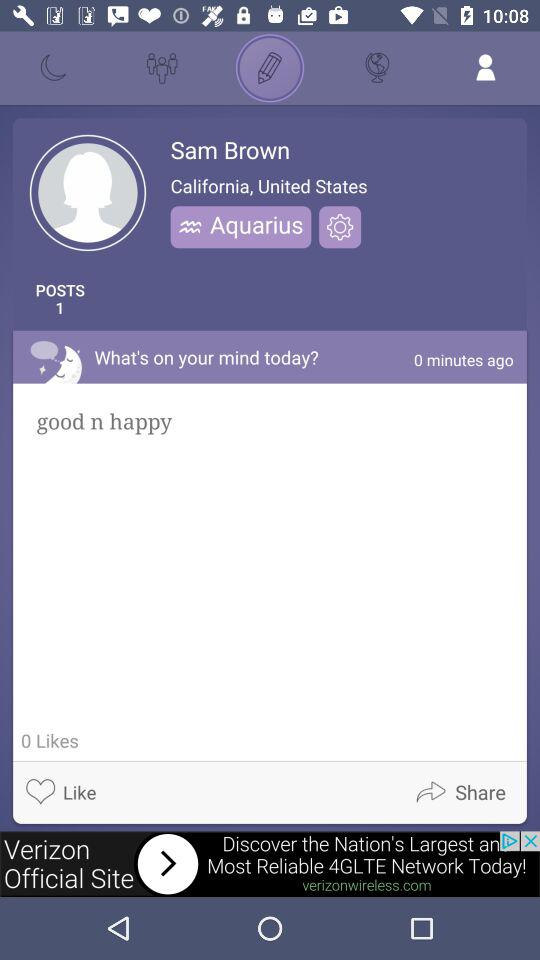What is the given zodiac sign? The given zodiac sign is Aquarius. 